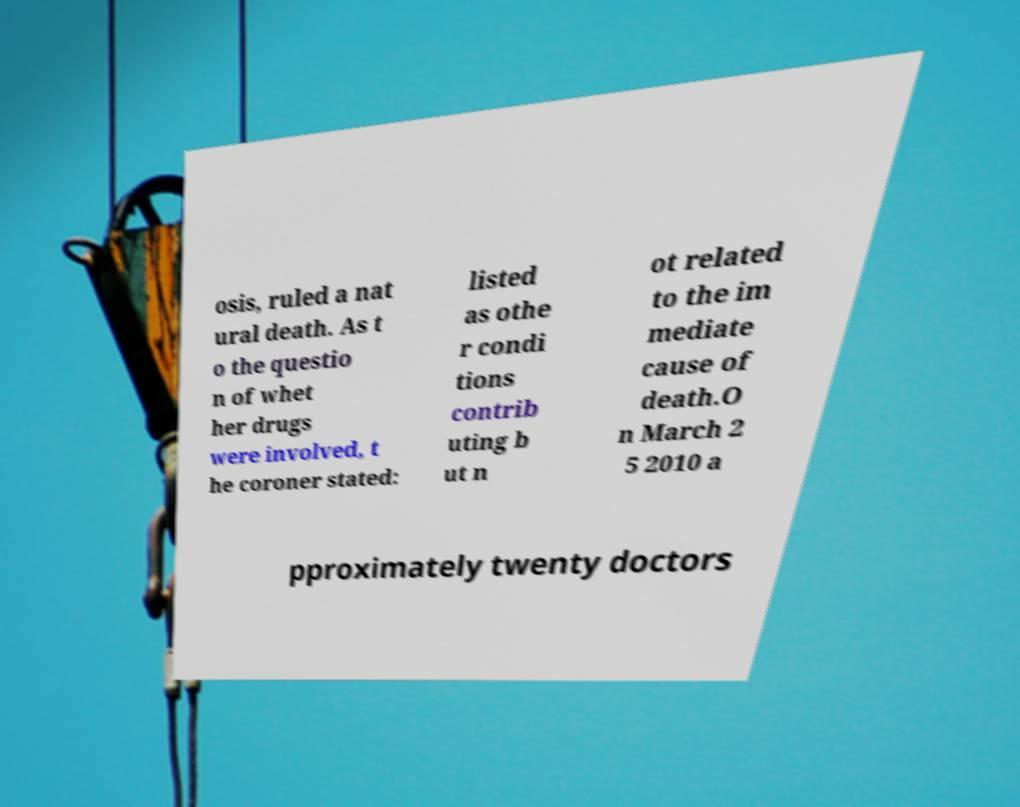Could you assist in decoding the text presented in this image and type it out clearly? osis, ruled a nat ural death. As t o the questio n of whet her drugs were involved, t he coroner stated: listed as othe r condi tions contrib uting b ut n ot related to the im mediate cause of death.O n March 2 5 2010 a pproximately twenty doctors 